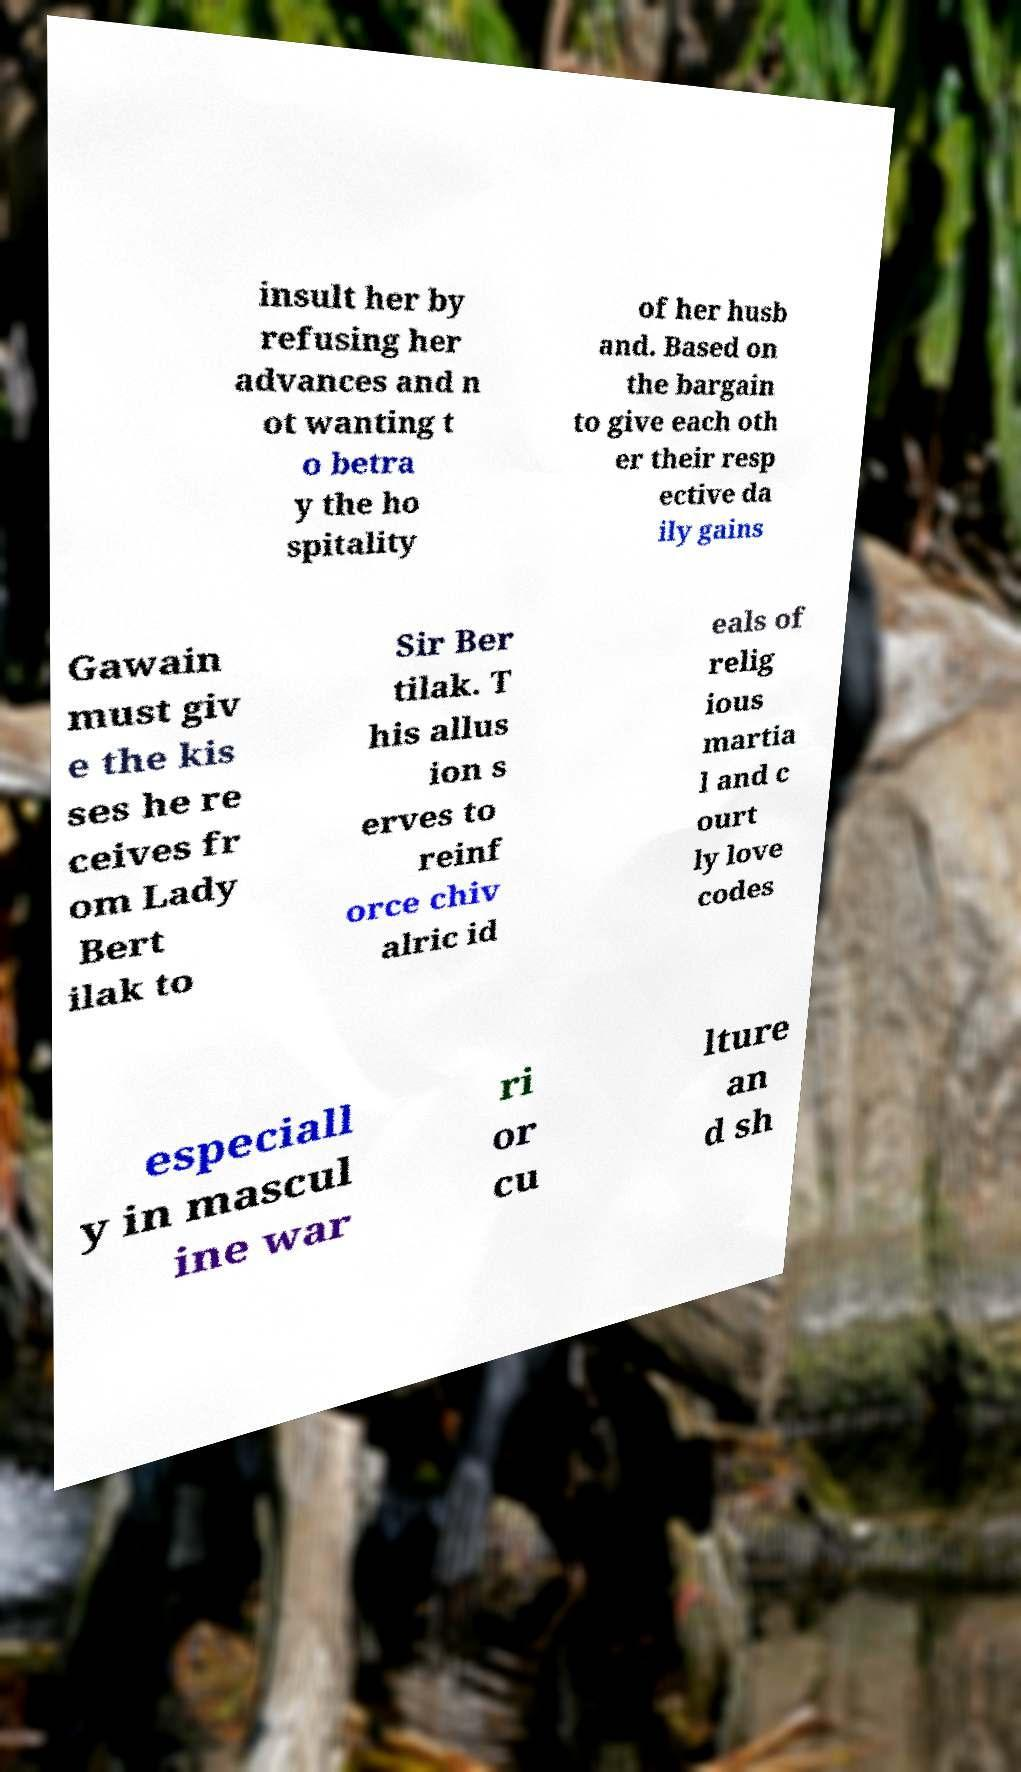For documentation purposes, I need the text within this image transcribed. Could you provide that? insult her by refusing her advances and n ot wanting t o betra y the ho spitality of her husb and. Based on the bargain to give each oth er their resp ective da ily gains Gawain must giv e the kis ses he re ceives fr om Lady Bert ilak to Sir Ber tilak. T his allus ion s erves to reinf orce chiv alric id eals of relig ious martia l and c ourt ly love codes especiall y in mascul ine war ri or cu lture an d sh 